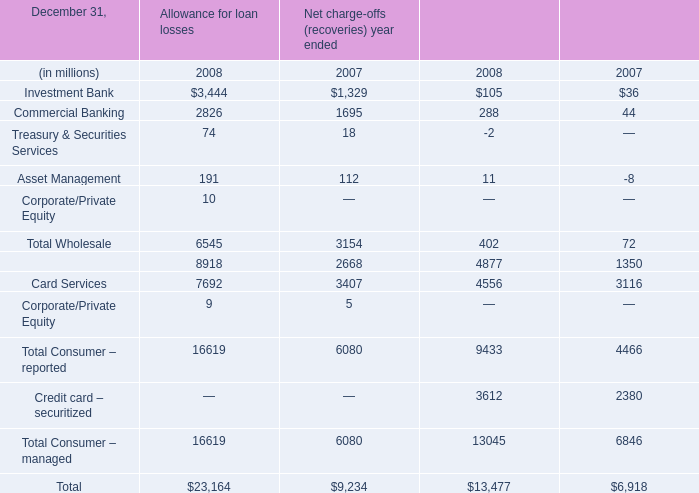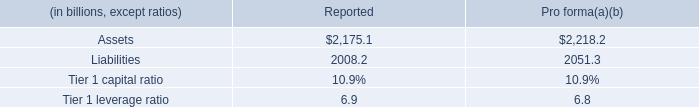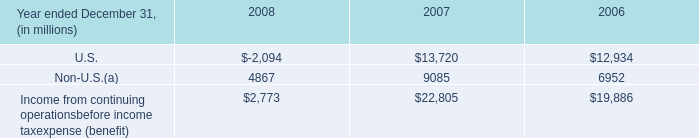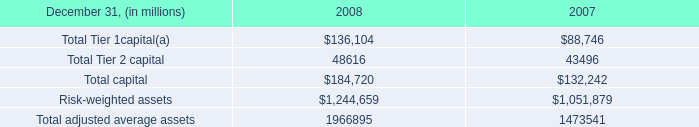without foreign operations in 2008 , what would the pre-tax income from continuing operations be? 
Computations: ((2773 - 4867) * 1000000)
Answer: -2094000000.0. 